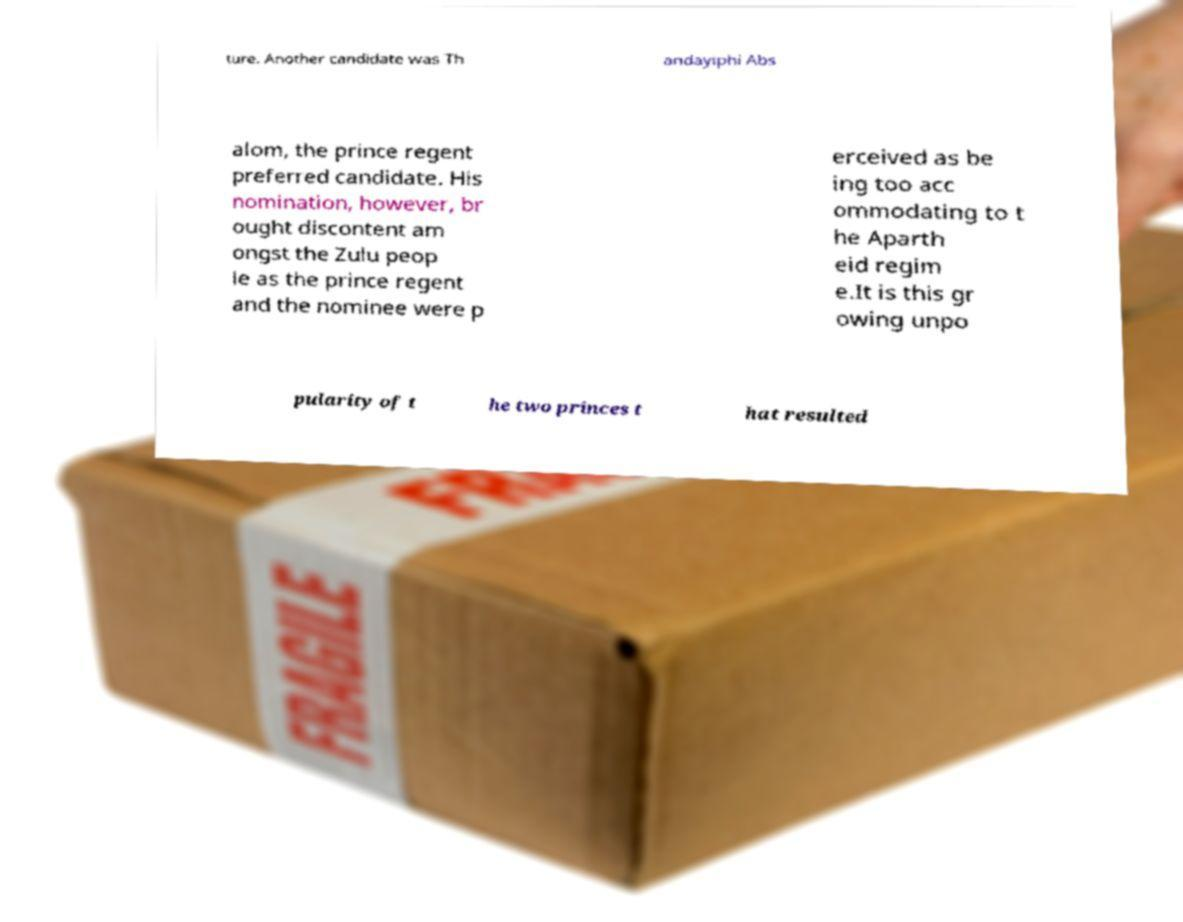Could you assist in decoding the text presented in this image and type it out clearly? ture. Another candidate was Th andayiphi Abs alom, the prince regent preferred candidate. His nomination, however, br ought discontent am ongst the Zulu peop le as the prince regent and the nominee were p erceived as be ing too acc ommodating to t he Aparth eid regim e.It is this gr owing unpo pularity of t he two princes t hat resulted 